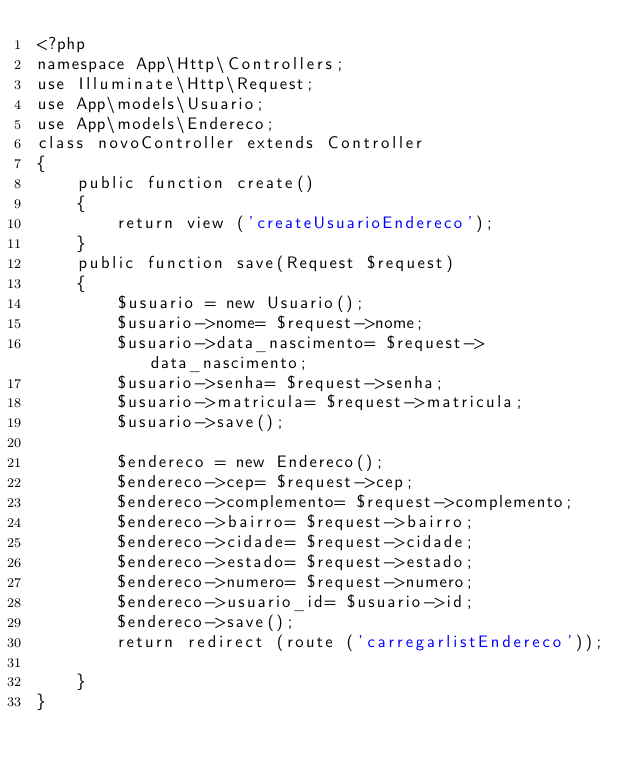<code> <loc_0><loc_0><loc_500><loc_500><_PHP_><?php
namespace App\Http\Controllers;
use Illuminate\Http\Request;
use App\models\Usuario;
use App\models\Endereco;
class novoController extends Controller
{
    public function create()
    {
        return view ('createUsuarioEndereco');
    }
    public function save(Request $request)
    {
        $usuario = new Usuario();
        $usuario->nome= $request->nome;
        $usuario->data_nascimento= $request->data_nascimento;
        $usuario->senha= $request->senha;
        $usuario->matricula= $request->matricula;
        $usuario->save();

        $endereco = new Endereco();
        $endereco->cep= $request->cep;
        $endereco->complemento= $request->complemento;
        $endereco->bairro= $request->bairro;
        $endereco->cidade= $request->cidade;
        $endereco->estado= $request->estado;
        $endereco->numero= $request->numero;
        $endereco->usuario_id= $usuario->id;
        $endereco->save();
        return redirect (route ('carregarlistEndereco'));

    }
}

</code> 